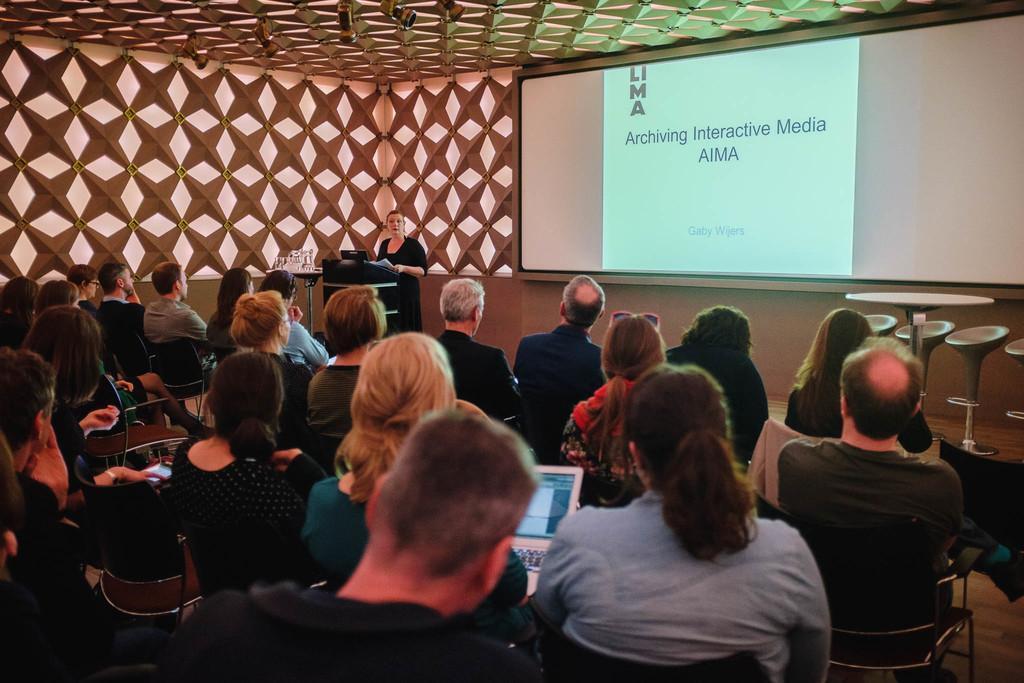In one or two sentences, can you explain what this image depicts? There are groups of people sitting on the chairs. I can see the woman holding a laptop. This is a woman standing. I think this is a podium. These are the chairs and a table. This is the screen with the display, which is attached to the wall. I think these are the lights, which are attached to the ceiling. 